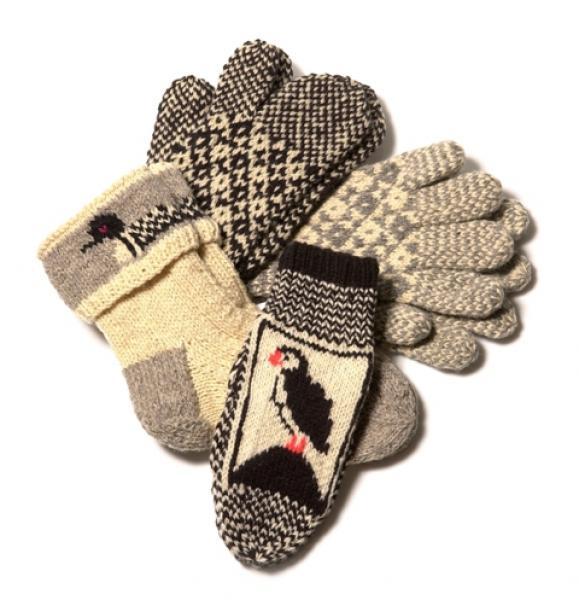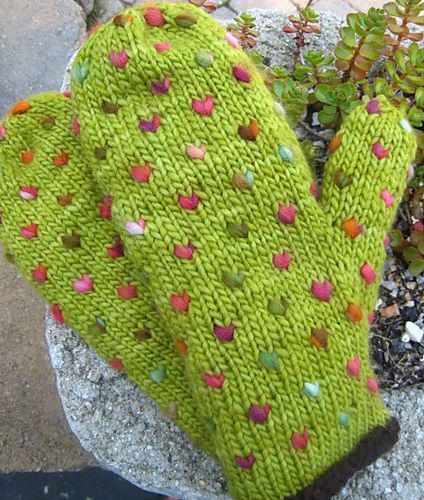The first image is the image on the left, the second image is the image on the right. Given the left and right images, does the statement "The mittens in one of the images are lying on a wooden surface" hold true? Answer yes or no. No. The first image is the image on the left, the second image is the image on the right. Considering the images on both sides, is "There are gloves with heart pattern shown." valid? Answer yes or no. Yes. 